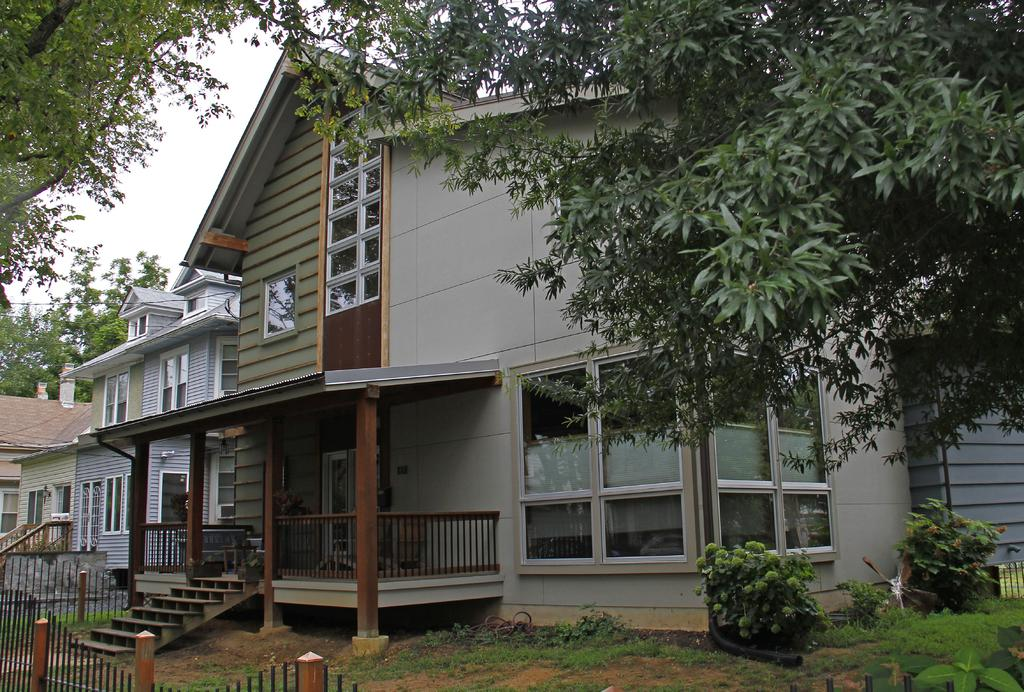What type of structures can be seen in the image? There are buildings in the image. What other natural elements are present in the image? There are trees and plants in the image. Are there any architectural features visible in the image? Yes, there are stairs in the image. What type of barrier can be seen in the image? There is a fence in the image. What part of the natural environment is visible in the image? The sky is visible in the image. What shape does the error take in the image? There is no error present in the image, so it cannot be assigned a shape. 